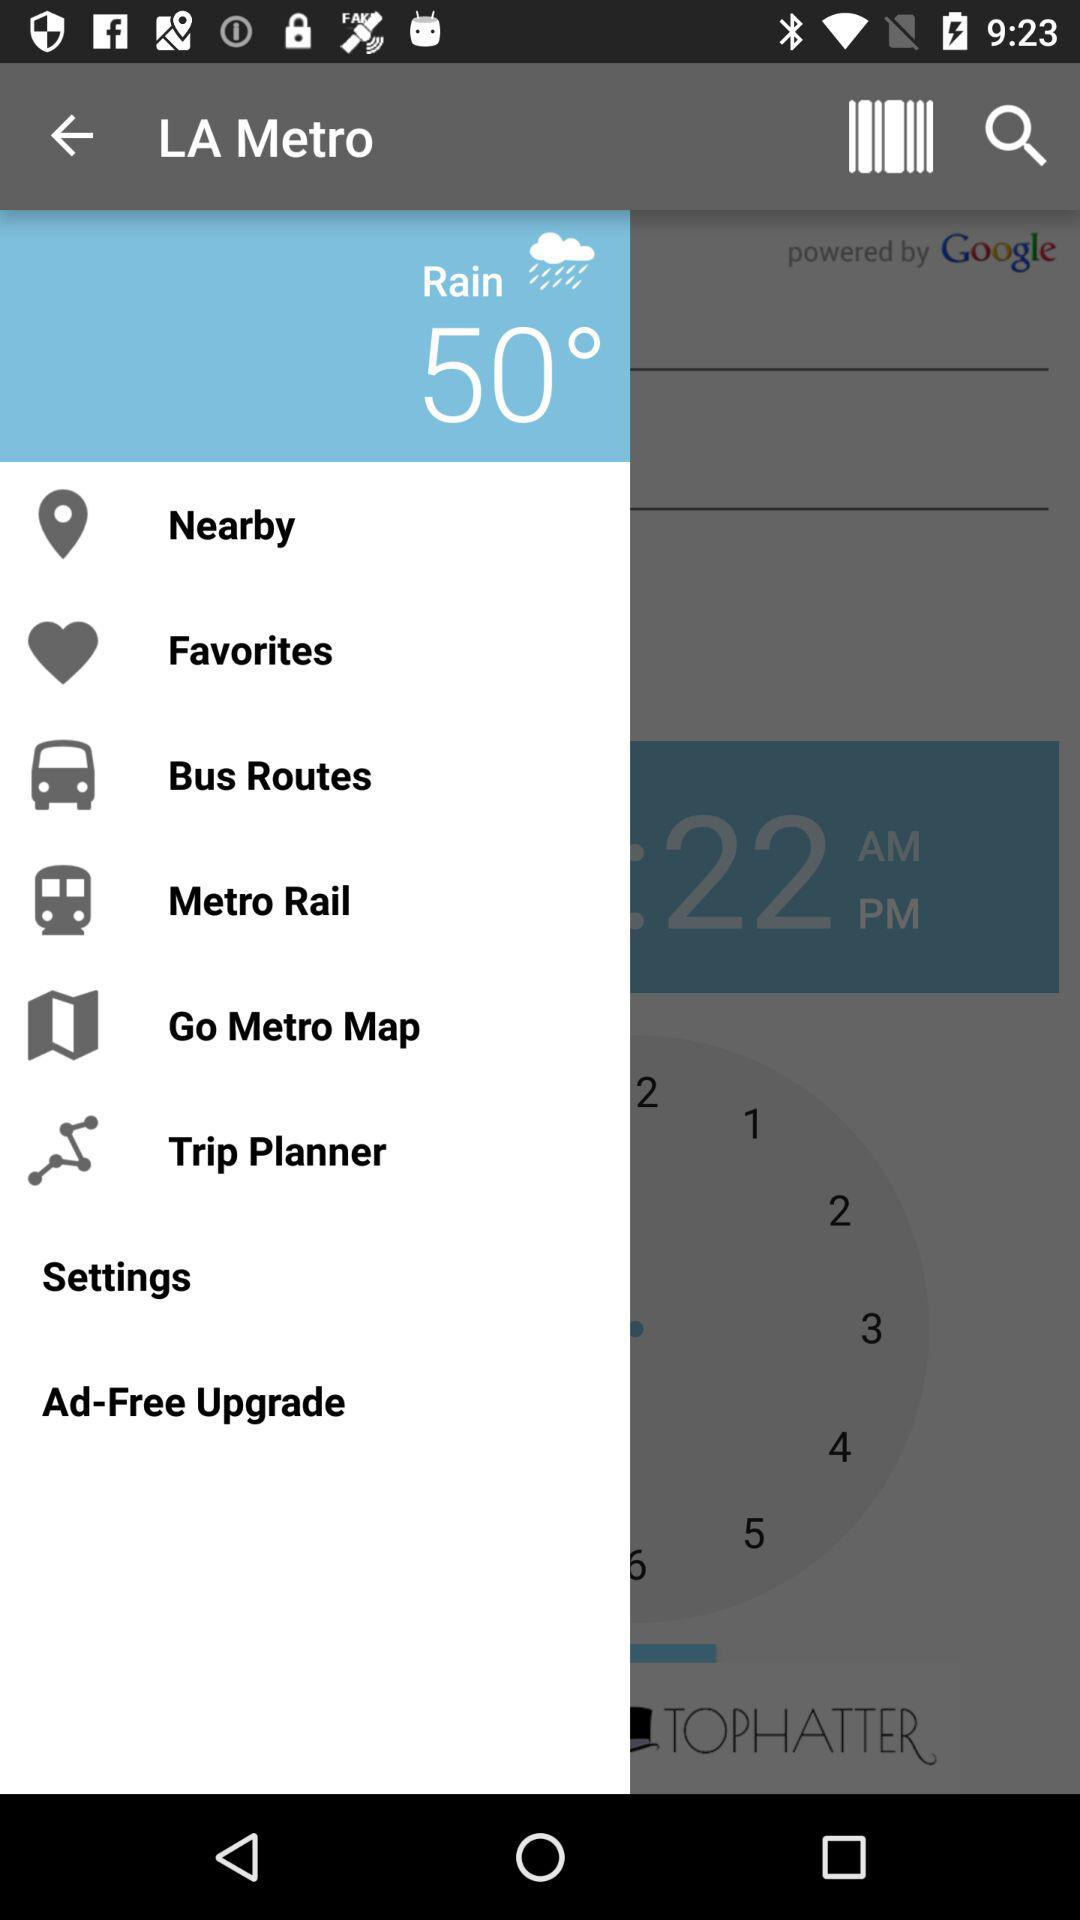What is the weather forecast? The weather is rainy and the temperature is 50 degrees. 